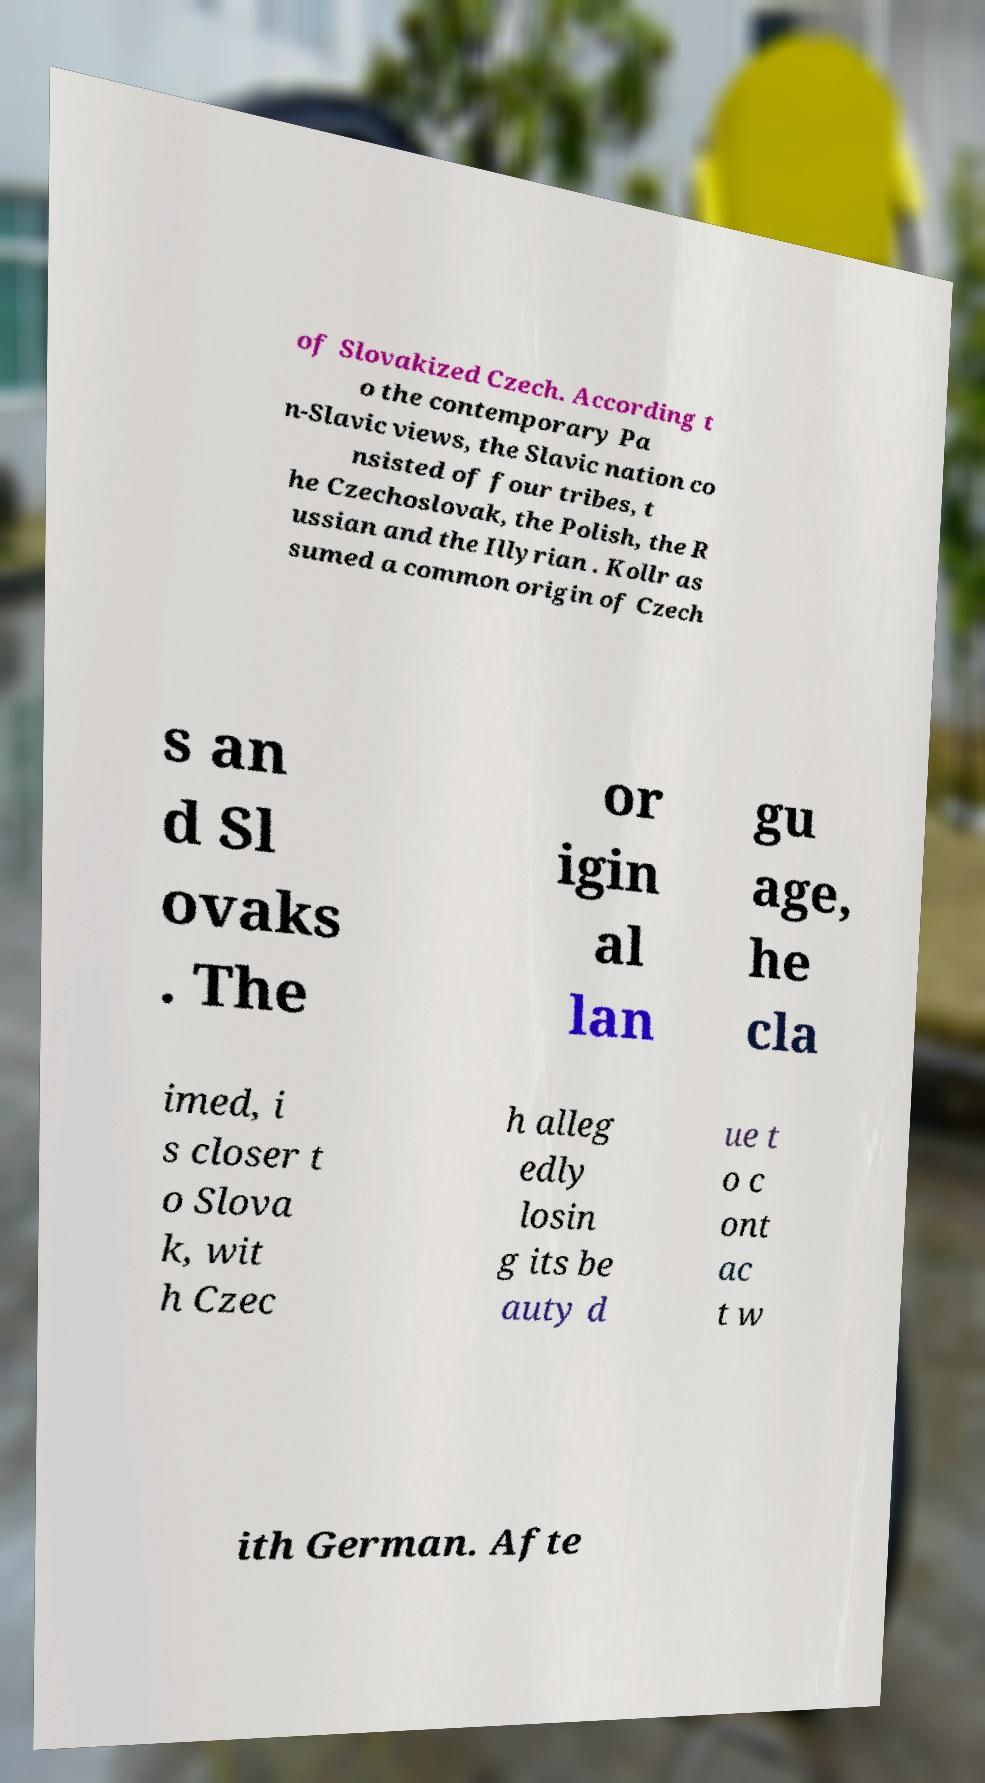For documentation purposes, I need the text within this image transcribed. Could you provide that? of Slovakized Czech. According t o the contemporary Pa n-Slavic views, the Slavic nation co nsisted of four tribes, t he Czechoslovak, the Polish, the R ussian and the Illyrian . Kollr as sumed a common origin of Czech s an d Sl ovaks . The or igin al lan gu age, he cla imed, i s closer t o Slova k, wit h Czec h alleg edly losin g its be auty d ue t o c ont ac t w ith German. Afte 